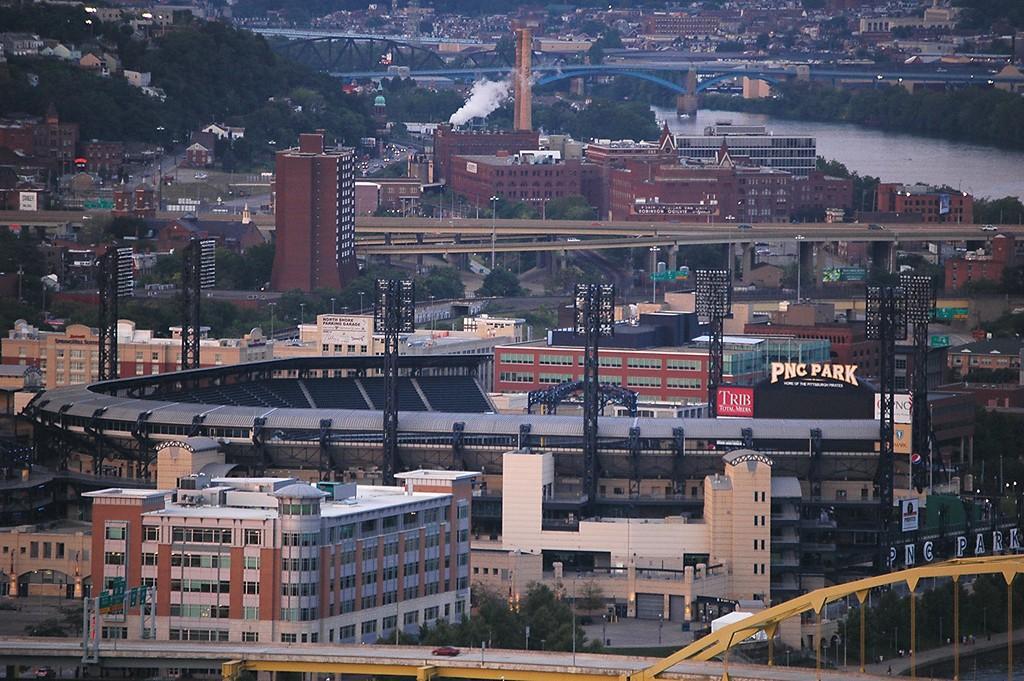Can you describe this image briefly? This picture is clicked outside the city. In this picture, there are many buildings. In the middle of the picture, we see a stadium and a park. We even see street lights, towers and poles. In the background, there are trees and buildings. We even see a bridge. On the right side of the picture, we see water. At the bottom of the picture, we see a red car moving on the bridge. 